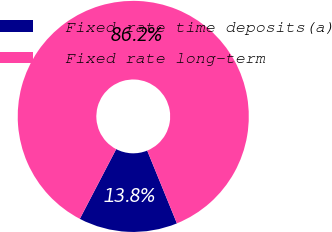<chart> <loc_0><loc_0><loc_500><loc_500><pie_chart><fcel>Fixed rate time deposits(a)<fcel>Fixed rate long-term<nl><fcel>13.82%<fcel>86.18%<nl></chart> 